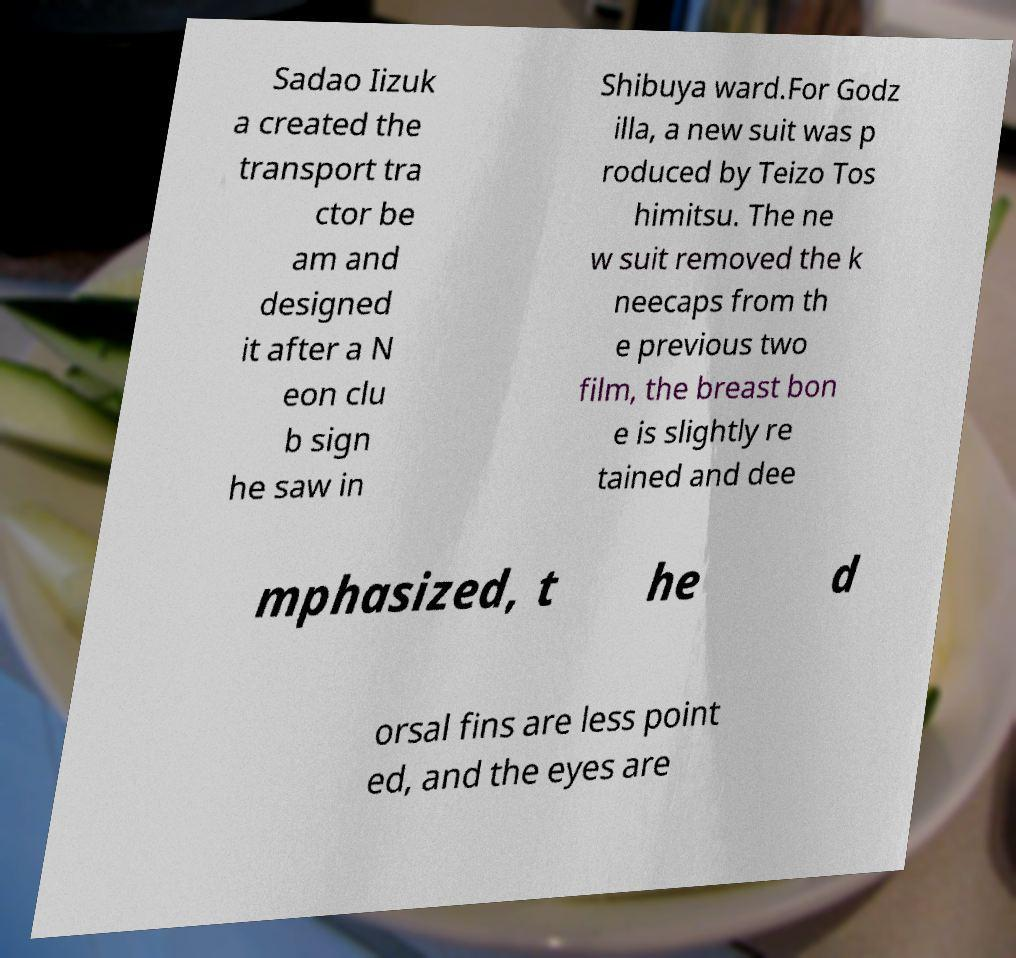Can you read and provide the text displayed in the image?This photo seems to have some interesting text. Can you extract and type it out for me? Sadao Iizuk a created the transport tra ctor be am and designed it after a N eon clu b sign he saw in Shibuya ward.For Godz illa, a new suit was p roduced by Teizo Tos himitsu. The ne w suit removed the k neecaps from th e previous two film, the breast bon e is slightly re tained and dee mphasized, t he d orsal fins are less point ed, and the eyes are 